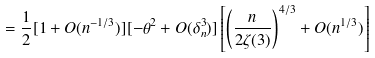<formula> <loc_0><loc_0><loc_500><loc_500>= \frac { 1 } { 2 } [ 1 + O ( n ^ { - 1 / 3 } ) ] [ - \theta ^ { 2 } + O ( \delta _ { n } ^ { 3 } ) ] \left [ \left ( \frac { n } { 2 \zeta ( 3 ) } \right ) ^ { 4 / 3 } + O ( n ^ { 1 / 3 } ) \right ]</formula> 